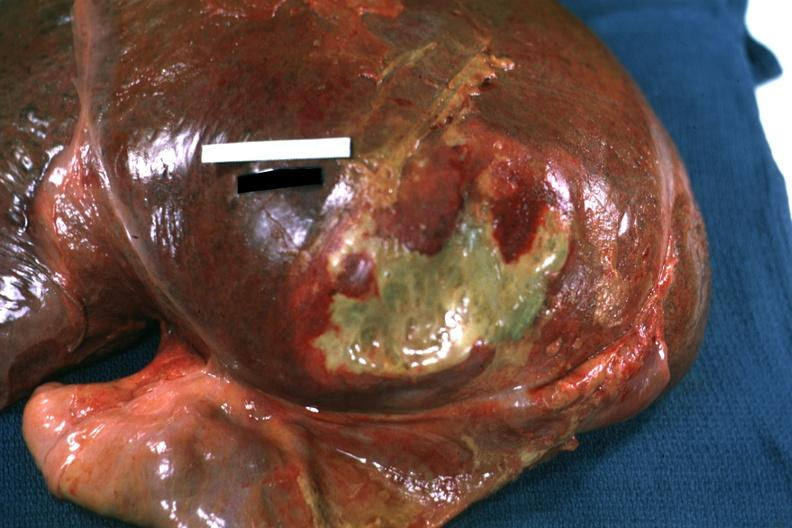how is right leaf of diaphragm reflected to show flat mass of green pus quite good example?
Answer the question using a single word or phrase. Yellow 